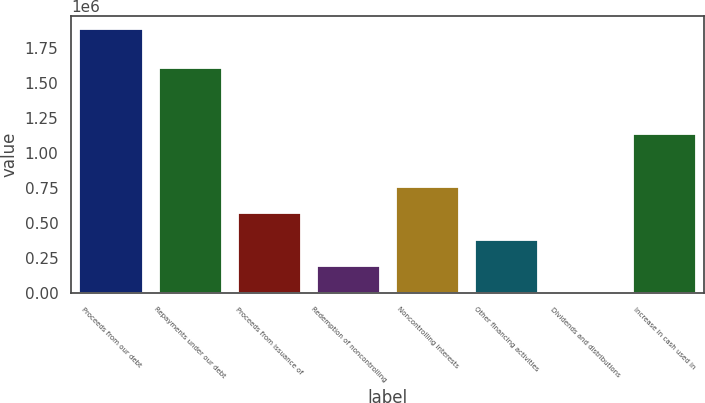Convert chart. <chart><loc_0><loc_0><loc_500><loc_500><bar_chart><fcel>Proceeds from our debt<fcel>Repayments under our debt<fcel>Proceeds from issuance of<fcel>Redemption of noncontrolling<fcel>Noncontrolling interests<fcel>Other financing activities<fcel>Dividends and distributions<fcel>Increase in cash used in<nl><fcel>1.88772e+06<fcel>1.61206e+06<fcel>569732<fcel>193165<fcel>758016<fcel>381449<fcel>4882<fcel>1.13458e+06<nl></chart> 